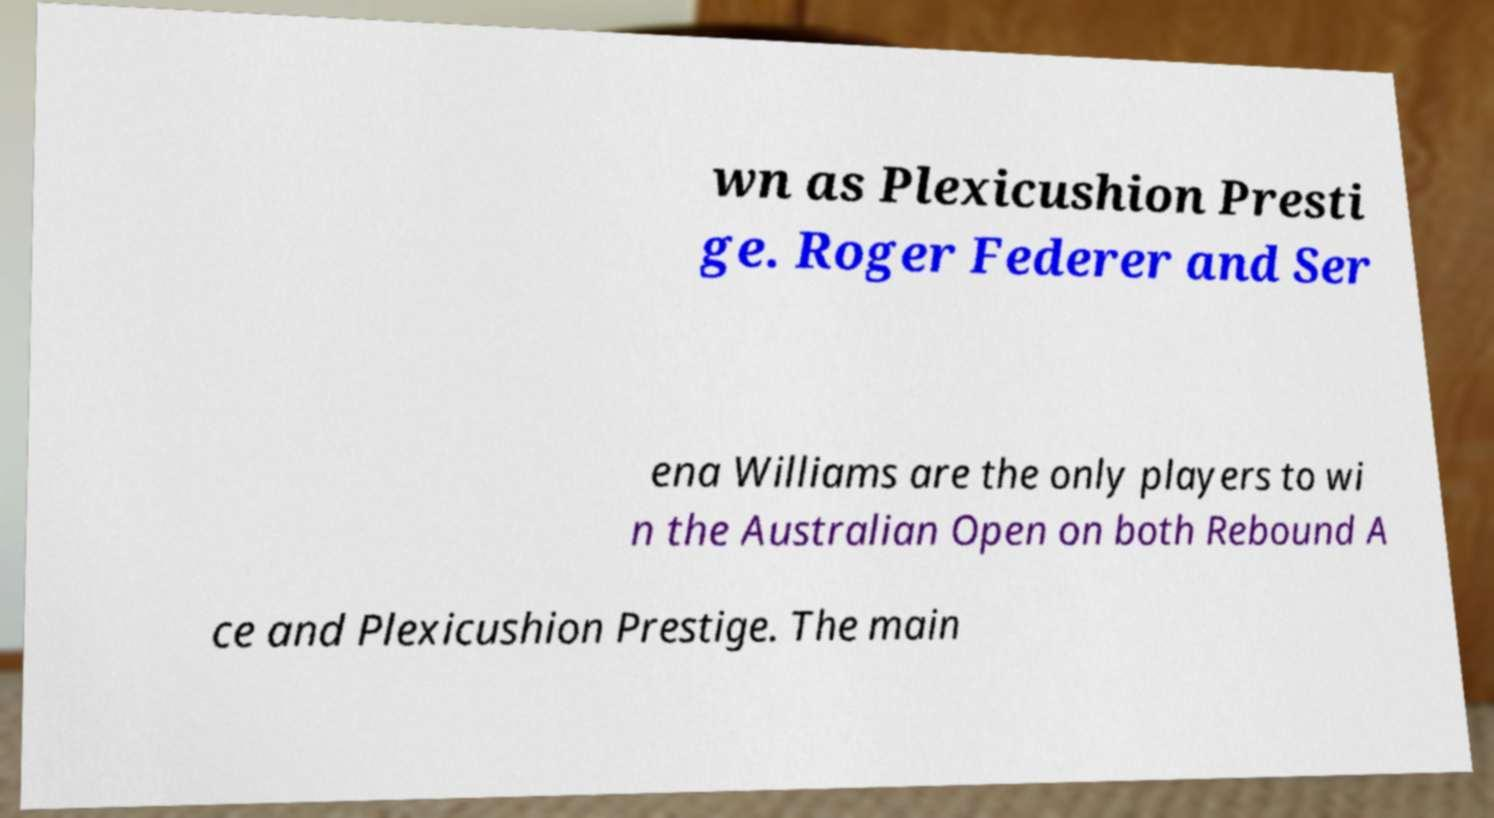Can you read and provide the text displayed in the image?This photo seems to have some interesting text. Can you extract and type it out for me? wn as Plexicushion Presti ge. Roger Federer and Ser ena Williams are the only players to wi n the Australian Open on both Rebound A ce and Plexicushion Prestige. The main 